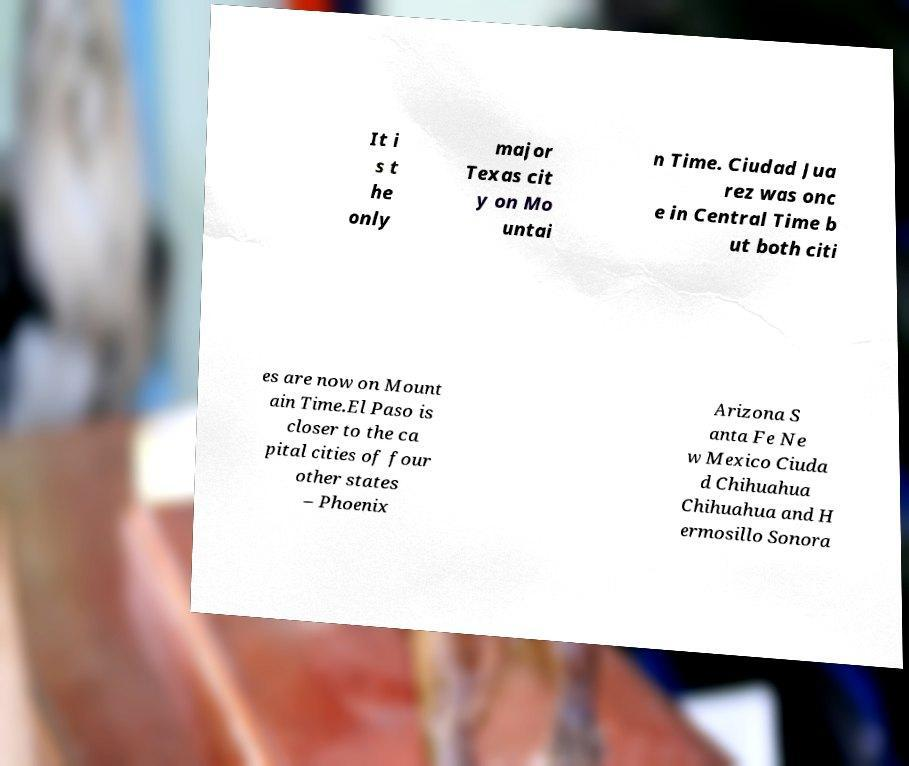What messages or text are displayed in this image? I need them in a readable, typed format. It i s t he only major Texas cit y on Mo untai n Time. Ciudad Jua rez was onc e in Central Time b ut both citi es are now on Mount ain Time.El Paso is closer to the ca pital cities of four other states – Phoenix Arizona S anta Fe Ne w Mexico Ciuda d Chihuahua Chihuahua and H ermosillo Sonora 